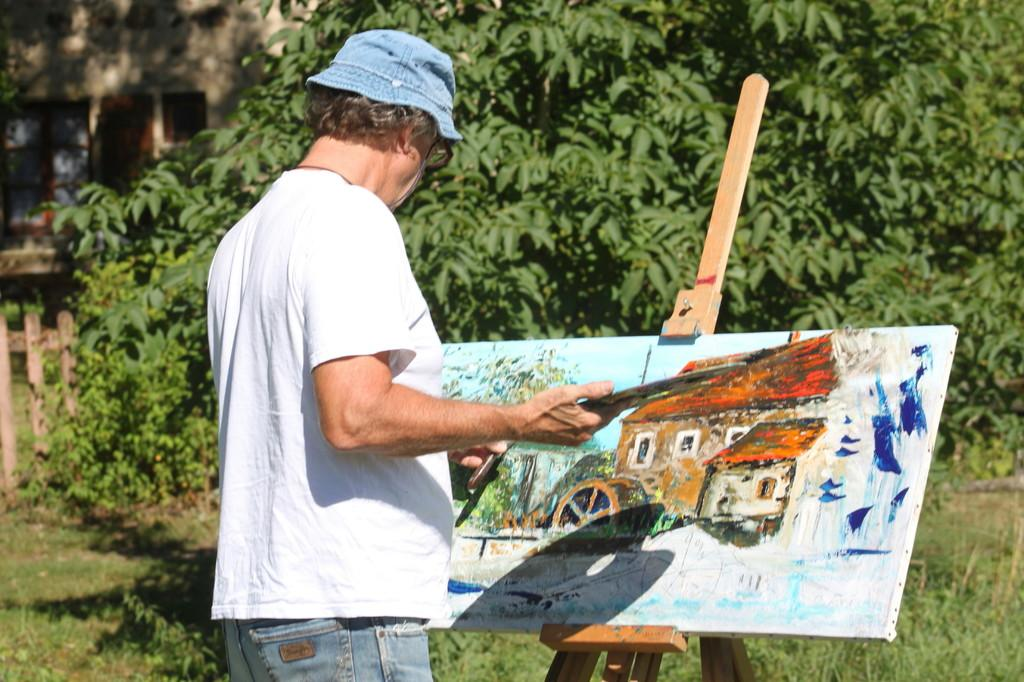Who is present in the image? There is a man in the image. Where is the man located? The man is standing in a garden. What is the man doing in the image? The man is painting on a sheet. What can be seen in the background of the image? There are trees and a building visible in the background of the image. How many goldfish are swimming in the pond in the image? There is no pond or goldfish present in the image. What type of cast is visible in the image? There is no cast present in the image. 